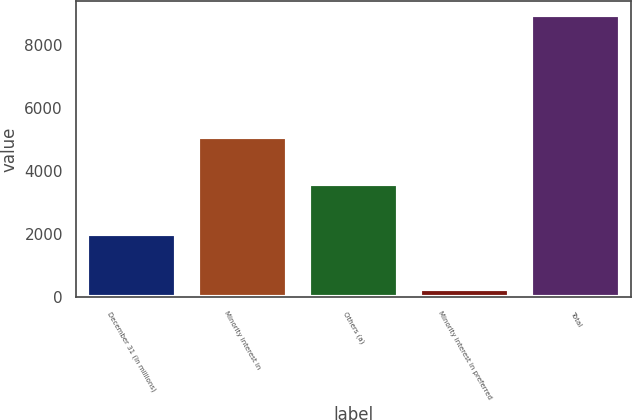Convert chart. <chart><loc_0><loc_0><loc_500><loc_500><bar_chart><fcel>December 31 (In millions)<fcel>Minority interest in<fcel>Others (a)<fcel>Minority interest in preferred<fcel>Total<nl><fcel>2008<fcel>5091<fcel>3579<fcel>277<fcel>8947<nl></chart> 